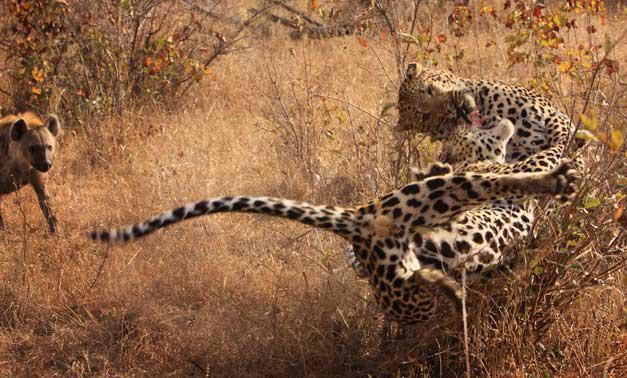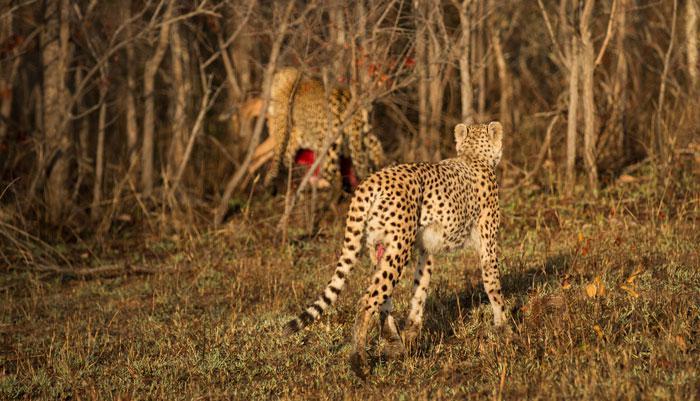The first image is the image on the left, the second image is the image on the right. For the images shown, is this caption "There is a cheetah with a dead caracal in one image, and two cheetahs in the other image." true? Answer yes or no. No. 